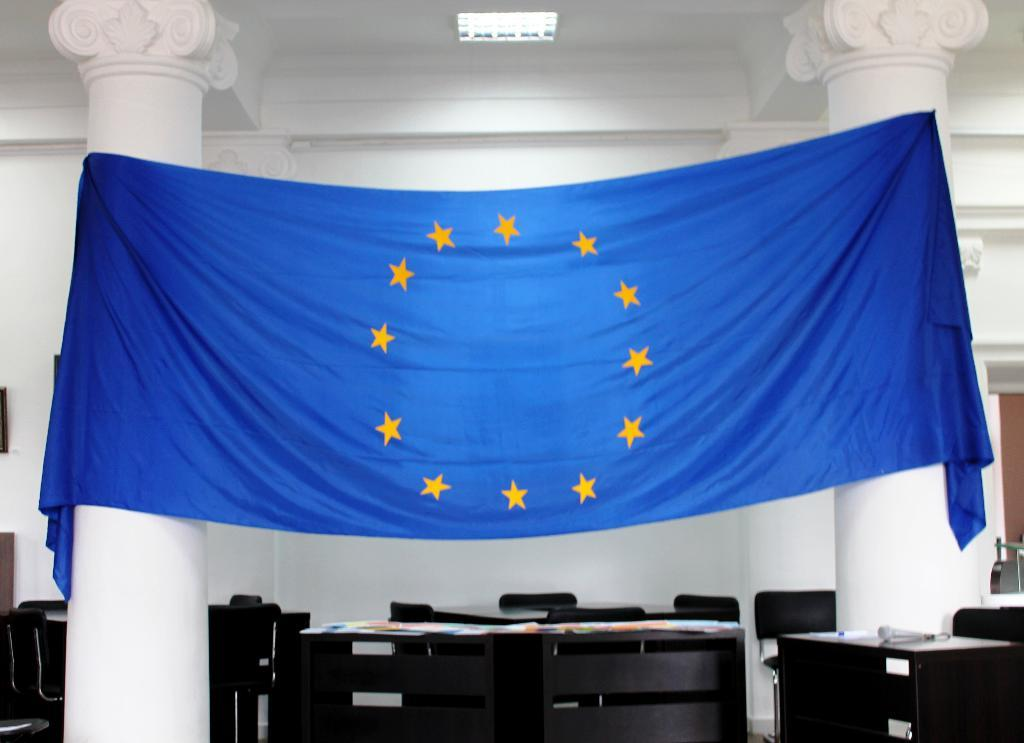What color is the cloth that is visible in the image? There is a blue cloth in the image. What type of architectural feature can be seen in the image? There are pillars in the image. What type of furniture is present in the image? There are chairs and a table in the image. What is visible in the background of the image? There is a wall in the background of the image. What type of illumination is present in the image? There is a light in the image. How many brothers are sitting on the chairs in the image? There is no mention of brothers in the image, and no people are visible. Can you see any yaks in the image? There are no yaks present in the image. 